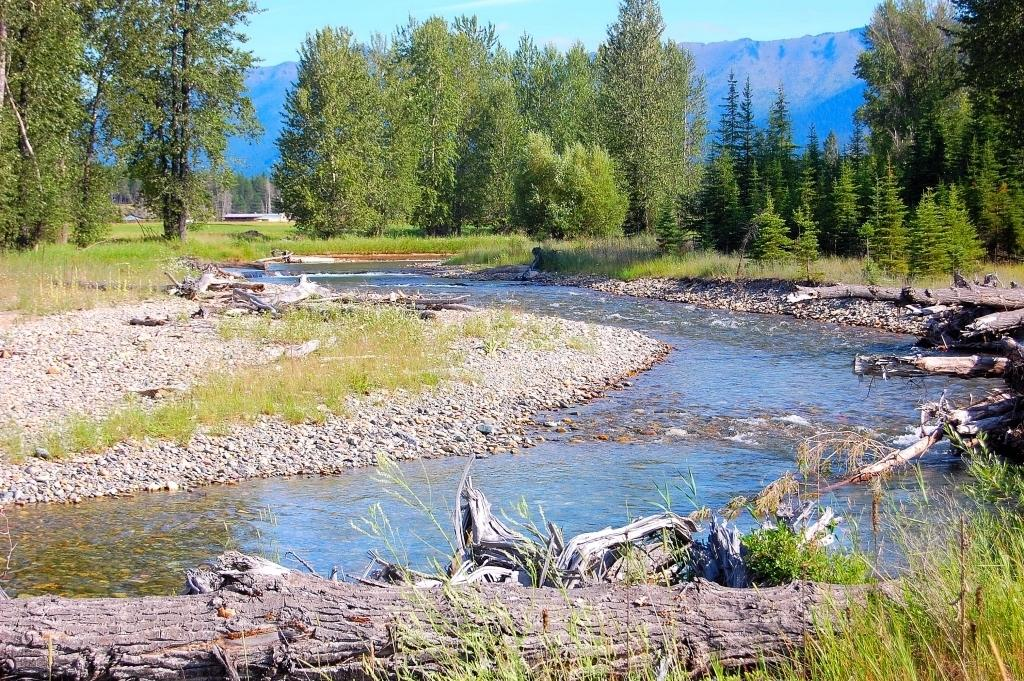What is happening in the middle of the image? Water is flowing in the middle of the image. What is located at the bottom of the image? There is a log at the bottom of the image. What type of vegetation can be seen in the image? There are trees in the image. What is visible at the top of the image? The sky is visible at the top of the image. What color is the pen on the cushion in the image? There is no pen or cushion present in the image. 